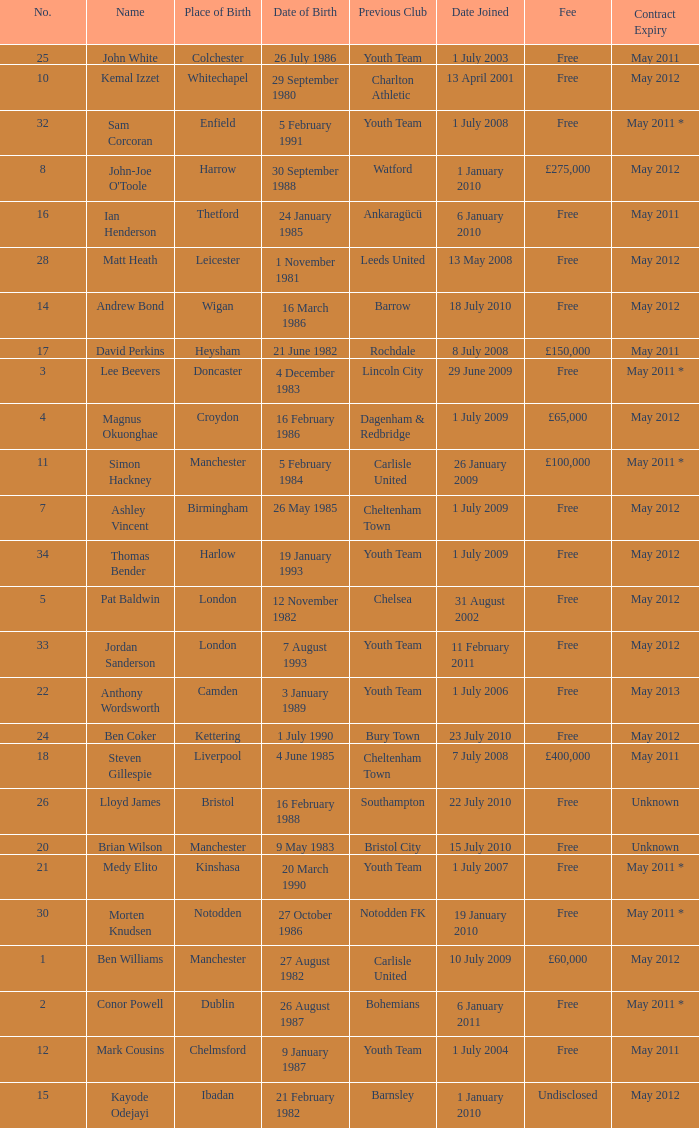What is the fee for ankaragücü previous club Free. 